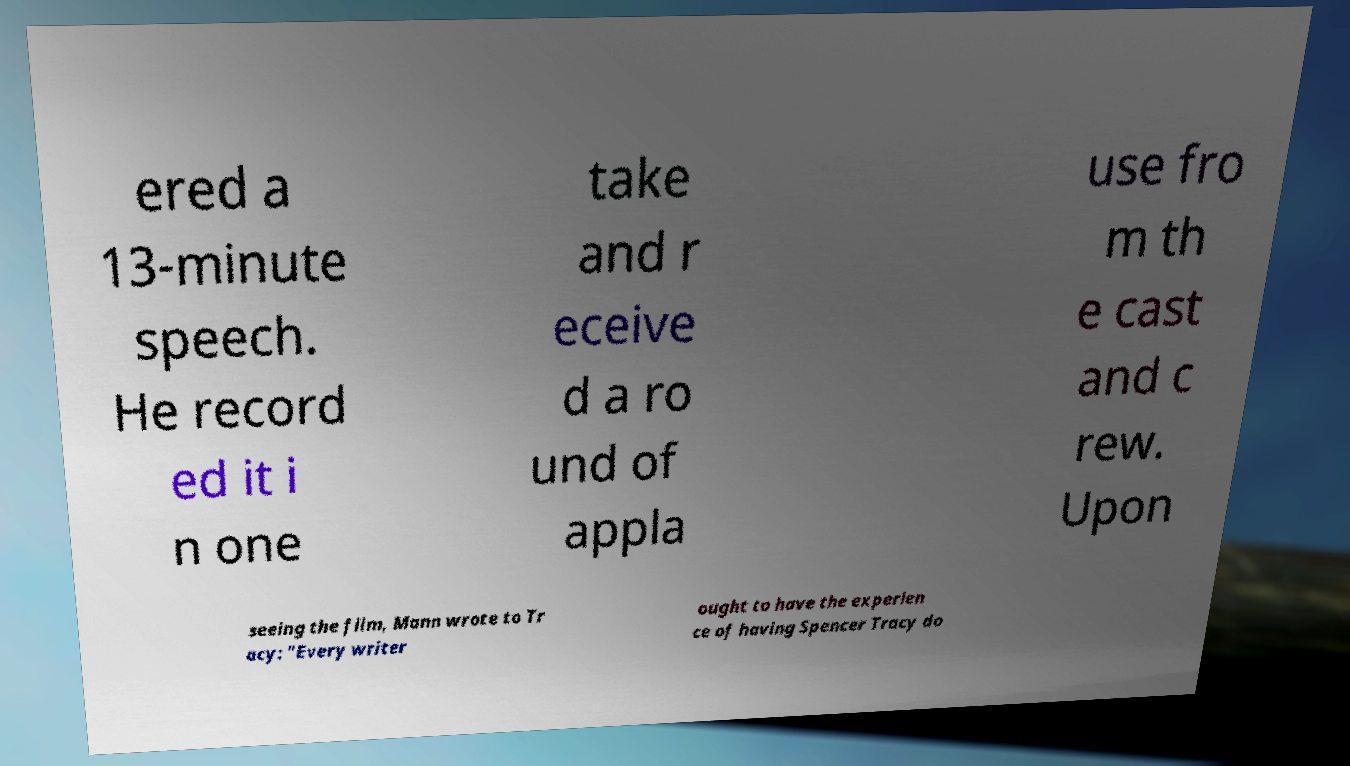Please identify and transcribe the text found in this image. ered a 13-minute speech. He record ed it i n one take and r eceive d a ro und of appla use fro m th e cast and c rew. Upon seeing the film, Mann wrote to Tr acy: "Every writer ought to have the experien ce of having Spencer Tracy do 